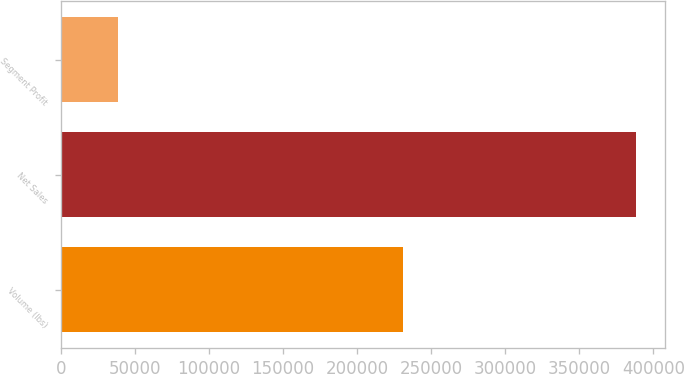Convert chart. <chart><loc_0><loc_0><loc_500><loc_500><bar_chart><fcel>Volume (lbs)<fcel>Net Sales<fcel>Segment Profit<nl><fcel>231180<fcel>388278<fcel>38744<nl></chart> 